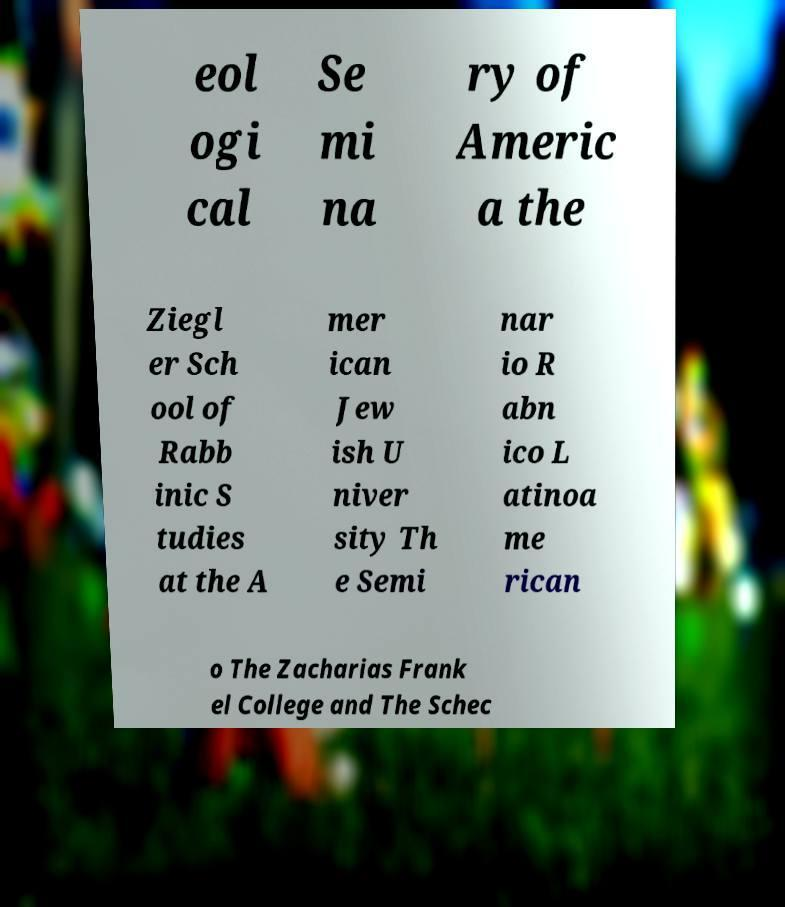What messages or text are displayed in this image? I need them in a readable, typed format. eol ogi cal Se mi na ry of Americ a the Ziegl er Sch ool of Rabb inic S tudies at the A mer ican Jew ish U niver sity Th e Semi nar io R abn ico L atinoa me rican o The Zacharias Frank el College and The Schec 